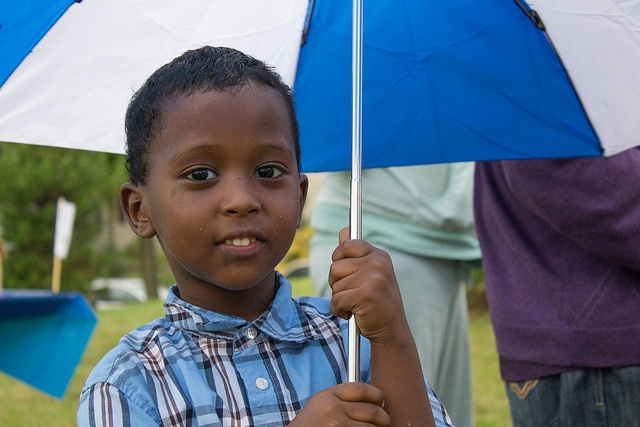Describe the objects in this image and their specific colors. I can see people in gray, maroon, and black tones, umbrella in gray, blue, and white tones, people in gray, black, and purple tones, people in gray, darkgray, and lightblue tones, and car in gray, darkgray, and darkgreen tones in this image. 